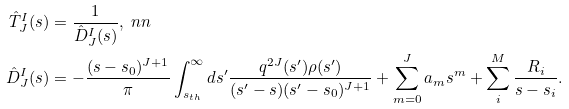Convert formula to latex. <formula><loc_0><loc_0><loc_500><loc_500>\hat { T } _ { J } ^ { I } ( s ) & = \frac { 1 } { { \hat { D } _ { J } ^ { I } ( s ) } } , \ n n \\ \hat { D } _ { J } ^ { I } ( s ) & = - \frac { ( s - s _ { 0 } ) ^ { J + 1 } } { \pi } \int _ { s _ { t h } } ^ { \infty } d s ^ { \prime } \frac { q ^ { 2 J } ( s ^ { \prime } ) \rho ( s ^ { \prime } ) } { ( s ^ { \prime } - s ) ( s ^ { \prime } - s _ { 0 } ) ^ { J + 1 } } + \sum _ { m = 0 } ^ { J } a _ { m } s ^ { m } + \sum _ { i } ^ { M } \frac { R _ { i } } { s - s _ { i } } .</formula> 